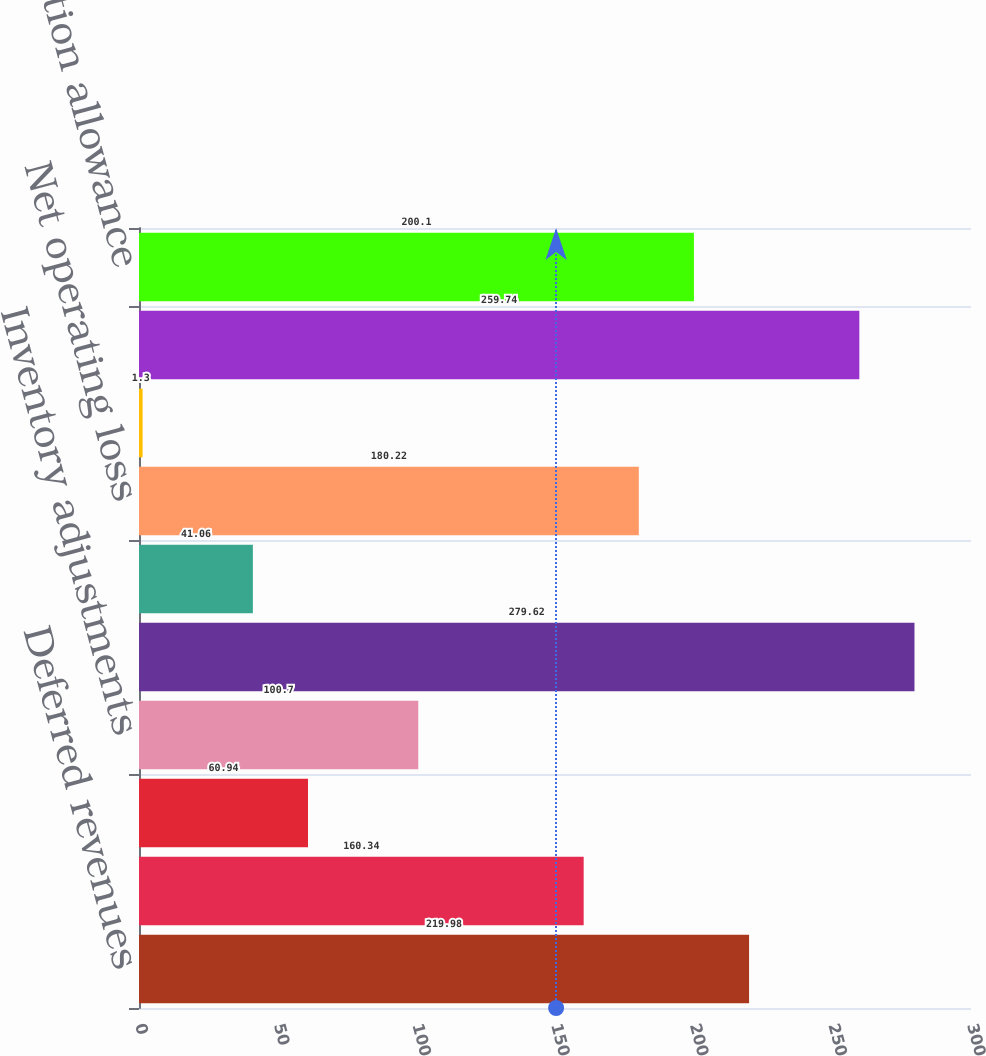Convert chart to OTSL. <chart><loc_0><loc_0><loc_500><loc_500><bar_chart><fcel>Deferred revenues<fcel>Deferred compensation<fcel>Product warranty<fcel>Inventory adjustments<fcel>Equity-based compensation<fcel>Environmental reserve<fcel>Net operating loss<fcel>Contingent loss reserve<fcel>Other<fcel>Valuation allowance<nl><fcel>219.98<fcel>160.34<fcel>60.94<fcel>100.7<fcel>279.62<fcel>41.06<fcel>180.22<fcel>1.3<fcel>259.74<fcel>200.1<nl></chart> 